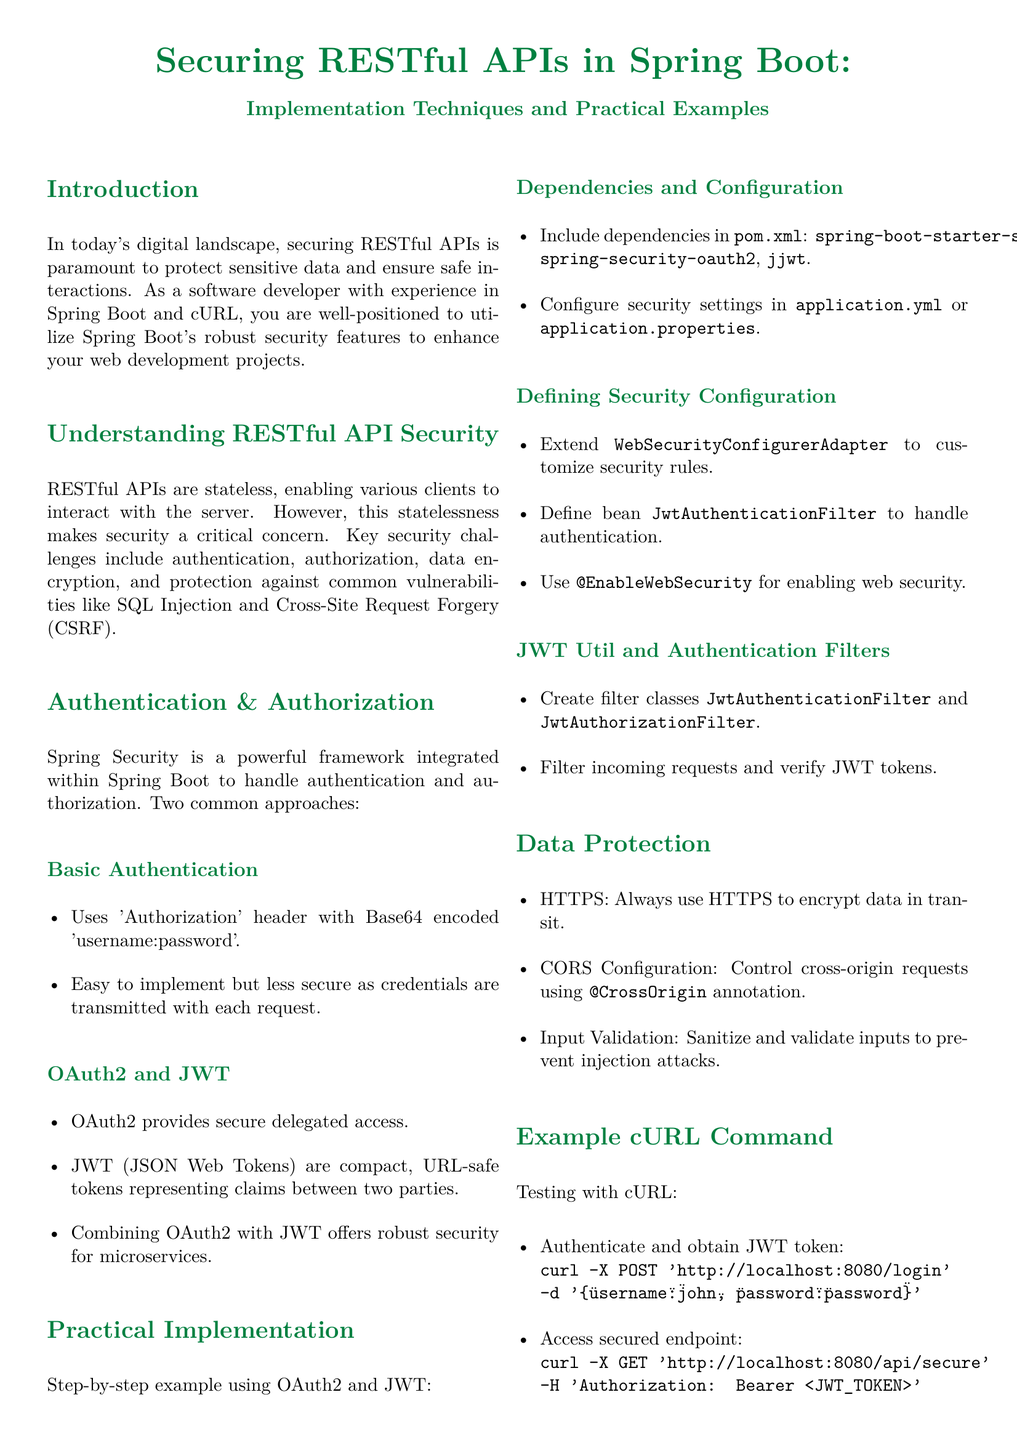What is the primary focus of this whitepaper? The whitepaper focuses on securing RESTful APIs in Spring Boot, detailing implementation techniques and examples.
Answer: Securing RESTful APIs in Spring Boot What is the key challenge related to RESTful APIs mentioned? The key challenge discussed is security, particularly around authentication and authorization.
Answer: Security Which authentication method is described as easy but less secure? Basic authentication is highlighted as a method that is easy to implement but less secure when transmitting credentials.
Answer: Basic authentication What framework is integrated within Spring Boot for handling security? The document states that Spring Security is the framework used for managing authentication and authorization in Spring Boot.
Answer: Spring Security Which two technologies combined offer robust security for microservices? The combination of OAuth2 and JWT is mentioned as providing robust security for microservices.
Answer: OAuth2 and JWT What command is used to access a secured endpoint with cURL? The command detailed for accessing a secured endpoint includes the use of 'Authorization: Bearer <JWT_TOKEN>'.
Answer: curl -X GET 'http://localhost:8080/api/secure' -H 'Authorization: Bearer <JWT_TOKEN>' What should be used to encrypt data in transit? The document recommends always using HTTPS to ensure that data is encrypted while being transmitted.
Answer: HTTPS What does CORS stand for in the context of data protection? CORS refers to Cross-Origin Resource Sharing, which is addressed for controlling requests.
Answer: Cross-Origin Resource Sharing What is the purpose of input validation as mentioned in the whitepaper? Input validation is important to prevent injection attacks by sanitizing and validating inputs.
Answer: Prevent injection attacks 